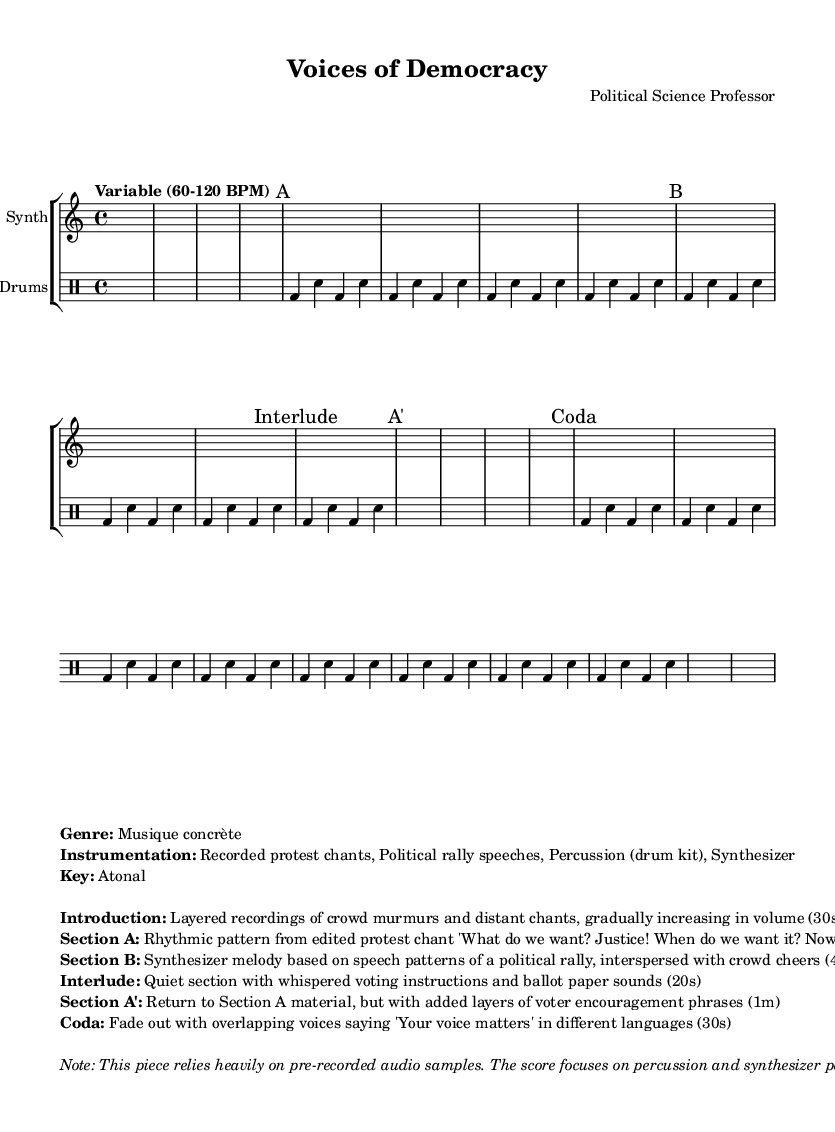What is the time signature of this music? The time signature is indicated at the beginning of the score. It shows that there are four beats per measure, which is written as 4/4.
Answer: 4/4 What is the tempo of this piece? The tempo is specified as "Variable (60-120 BPM)," suggesting that the speed can change within that range. It is not fixed to a single number.
Answer: Variable (60-120 BPM) What instruments are used in this composition? The instruments are listed in the instrumentation details of the score. They include "Recorded protest chants, Political rally speeches, Percussion (drum kit), Synthesizer."
Answer: Recorded protest chants, Political rally speeches, Percussion (drum kit), Synthesizer What is the character of Section A? Section A has a rhythmic pattern derived from the edited protest chant "What do we want? Justice! When do we want it? Now!", played with a steady drumbeat.
Answer: Rhythmic pattern from edited protest chant How long does the interlude last? The length of the interlude is specified in the score, which states it lasts for 20 seconds.
Answer: 20 seconds What kind of musical texture is employed during the coda? The coda features overlapping voices stating "Your voice matters" in various languages, which creates a rich and multi-layered texture typical of musique concrète.
Answer: Overlapping voices Why is the key of this piece described as atonal? The piece does not adhere to traditional tonal centers or key signatures, which is characteristic of atonal music. Instead, it focuses on sound textures and layering without establishing a traditional key.
Answer: Atonal 